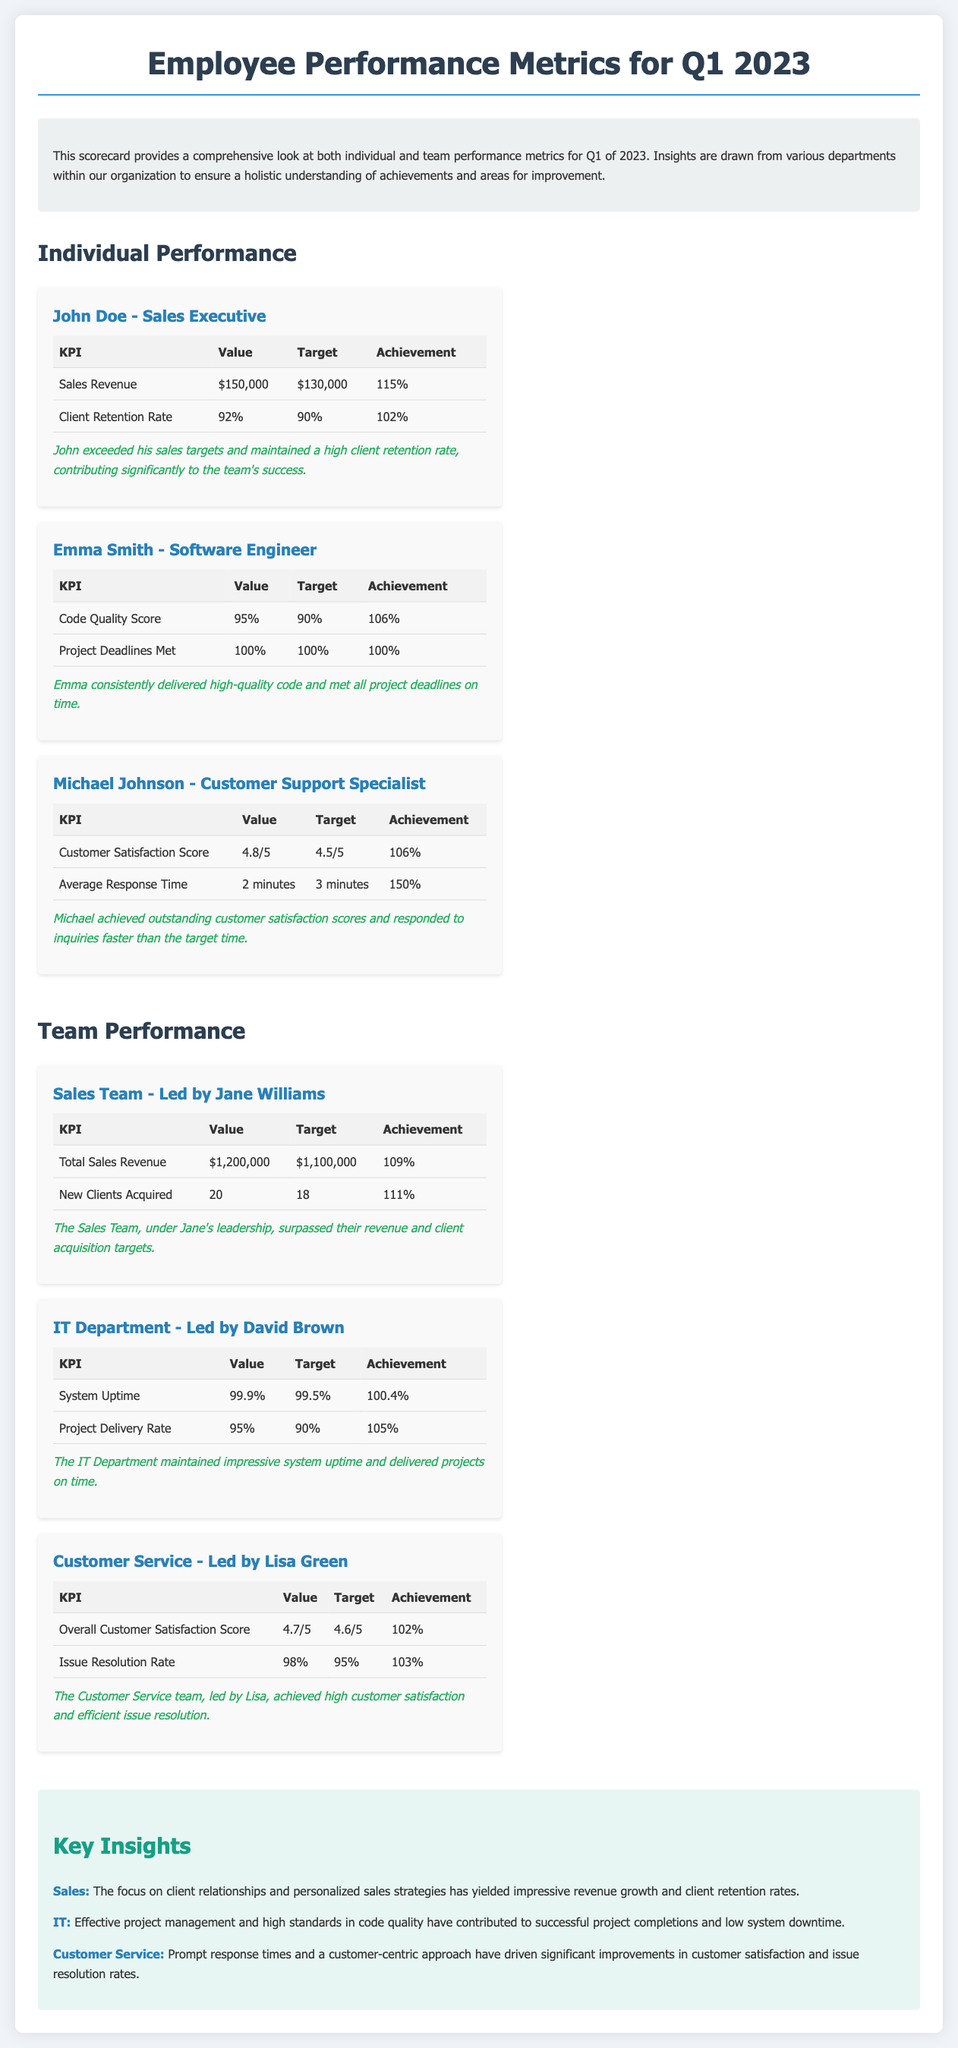What is the sales revenue achieved by John Doe? The sales revenue achieved by John Doe is $150,000, as stated in his performance metrics.
Answer: $150,000 What is Emma Smith's Code Quality Score? Emma Smith's Code Quality Score is 95%, which is noted in her individual performance metrics.
Answer: 95% What percentage of client retention rate did John Doe achieve? John Doe achieved a client retention rate of 92%, as shown in his performance metrics.
Answer: 92% What is the Customer Satisfaction Score for Michael Johnson? Michael Johnson's Customer Satisfaction Score is 4.8 out of 5, detailed in his performance evaluation.
Answer: 4.8/5 What was the total sales revenue for the Sales Team? The total sales revenue for the Sales Team is $1,200,000, as indicated in their performance summary.
Answer: $1,200,000 Who led the IT Department? The IT Department was led by David Brown, as mentioned in the team performance section.
Answer: David Brown What is the average response time achieved by Michael Johnson? The average response time achieved by Michael Johnson is 2 minutes, which is recorded in his performance metrics.
Answer: 2 minutes What was the project delivery rate for the IT Department? The project delivery rate for the IT Department is 95%, as documented in their performance metrics.
Answer: 95% Which team achieved a customer satisfaction score above the target? The Customer Service team, led by Lisa Green, achieved a customer satisfaction score above the target.
Answer: Customer Service team 